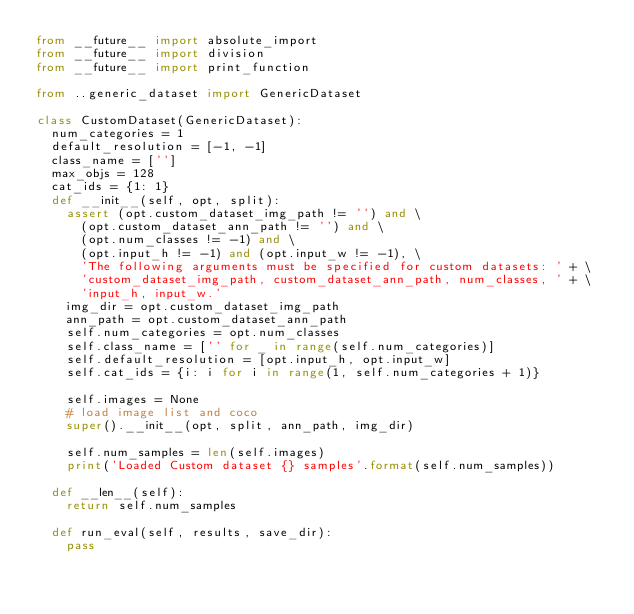Convert code to text. <code><loc_0><loc_0><loc_500><loc_500><_Python_>from __future__ import absolute_import
from __future__ import division
from __future__ import print_function

from ..generic_dataset import GenericDataset

class CustomDataset(GenericDataset):
  num_categories = 1
  default_resolution = [-1, -1]
  class_name = ['']
  max_objs = 128
  cat_ids = {1: 1}
  def __init__(self, opt, split):
    assert (opt.custom_dataset_img_path != '') and \
      (opt.custom_dataset_ann_path != '') and \
      (opt.num_classes != -1) and \
      (opt.input_h != -1) and (opt.input_w != -1), \
      'The following arguments must be specified for custom datasets: ' + \
      'custom_dataset_img_path, custom_dataset_ann_path, num_classes, ' + \
      'input_h, input_w.'
    img_dir = opt.custom_dataset_img_path
    ann_path = opt.custom_dataset_ann_path
    self.num_categories = opt.num_classes
    self.class_name = ['' for _ in range(self.num_categories)]
    self.default_resolution = [opt.input_h, opt.input_w]
    self.cat_ids = {i: i for i in range(1, self.num_categories + 1)}

    self.images = None
    # load image list and coco
    super().__init__(opt, split, ann_path, img_dir)

    self.num_samples = len(self.images)
    print('Loaded Custom dataset {} samples'.format(self.num_samples))
  
  def __len__(self):
    return self.num_samples

  def run_eval(self, results, save_dir):
    pass
</code> 